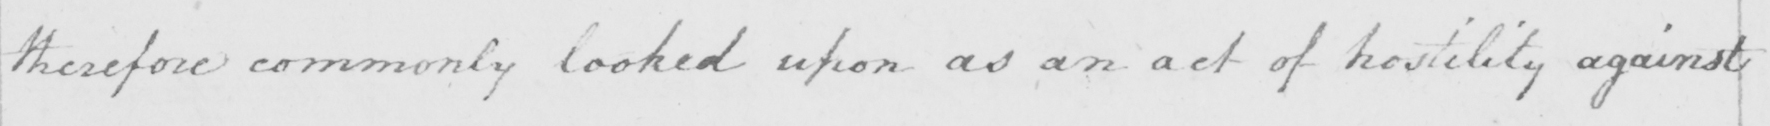What does this handwritten line say? therefore commonly looked upon as an act of hostility against 